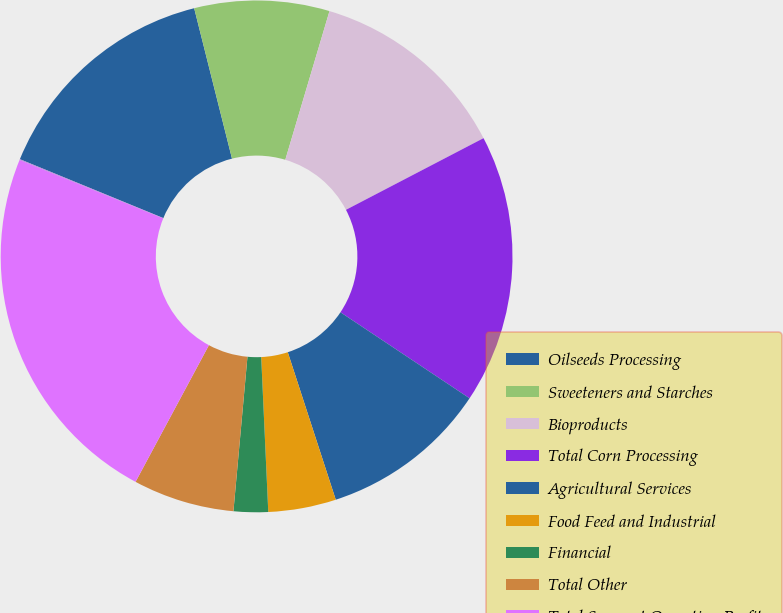Convert chart. <chart><loc_0><loc_0><loc_500><loc_500><pie_chart><fcel>Oilseeds Processing<fcel>Sweeteners and Starches<fcel>Bioproducts<fcel>Total Corn Processing<fcel>Agricultural Services<fcel>Food Feed and Industrial<fcel>Financial<fcel>Total Other<fcel>Total Segment Operating Profit<fcel>Corporate<nl><fcel>14.88%<fcel>8.52%<fcel>12.76%<fcel>17.0%<fcel>10.64%<fcel>4.28%<fcel>2.17%<fcel>6.4%<fcel>23.31%<fcel>0.05%<nl></chart> 